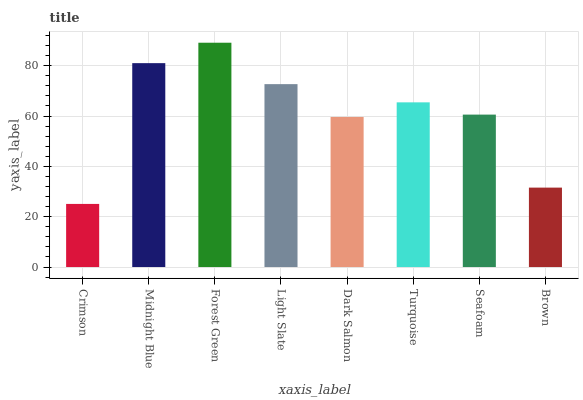Is Crimson the minimum?
Answer yes or no. Yes. Is Forest Green the maximum?
Answer yes or no. Yes. Is Midnight Blue the minimum?
Answer yes or no. No. Is Midnight Blue the maximum?
Answer yes or no. No. Is Midnight Blue greater than Crimson?
Answer yes or no. Yes. Is Crimson less than Midnight Blue?
Answer yes or no. Yes. Is Crimson greater than Midnight Blue?
Answer yes or no. No. Is Midnight Blue less than Crimson?
Answer yes or no. No. Is Turquoise the high median?
Answer yes or no. Yes. Is Seafoam the low median?
Answer yes or no. Yes. Is Forest Green the high median?
Answer yes or no. No. Is Light Slate the low median?
Answer yes or no. No. 